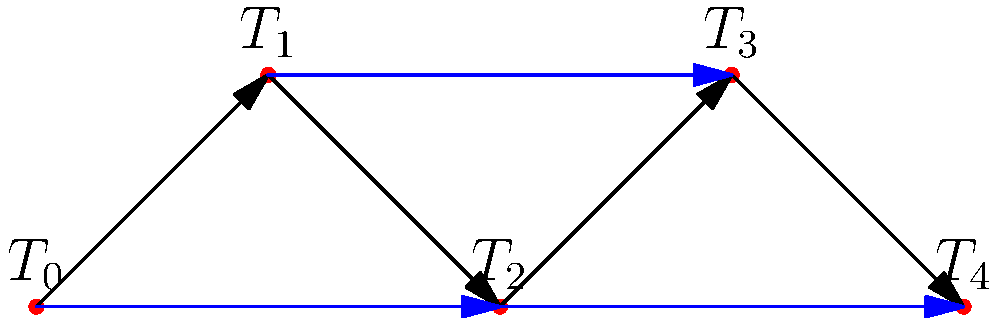In the directed graph representing timelines, blue arrows indicate potential time travel paths. To prevent paradoxes, what is the maximum number of blue arrows that can be traversed in a single time travel journey without creating a cycle? To solve this problem, we need to analyze the directed graph and understand how cycles can lead to paradoxes in time travel. Let's break it down step-by-step:

1. The graph represents different timelines ($T_0$ to $T_4$) connected by normal progression (black arrows) and potential time travel paths (blue arrows).

2. A cycle in this graph would represent a paradox, as it would allow returning to a previous point in time, potentially altering events that led to the time traveler's departure.

3. To find the maximum number of blue arrows that can be traversed without creating a cycle, we need to identify the longest path using only blue arrows that doesn't form a loop.

4. The blue arrows in the graph are:
   - $T_0$ to $T_2$
   - $T_1$ to $T_3$
   - $T_2$ to $T_4$

5. We can traverse these paths in the following ways:
   - $T_0$ to $T_2$ to $T_4$ (2 blue arrows)
   - $T_1$ to $T_3$ (1 blue arrow)

6. The longest path using blue arrows without creating a cycle is from $T_0$ to $T_2$ to $T_4$, which involves traversing 2 blue arrows.

Therefore, the maximum number of blue arrows that can be traversed in a single time travel journey without creating a cycle (and thus preventing paradoxes) is 2.
Answer: 2 